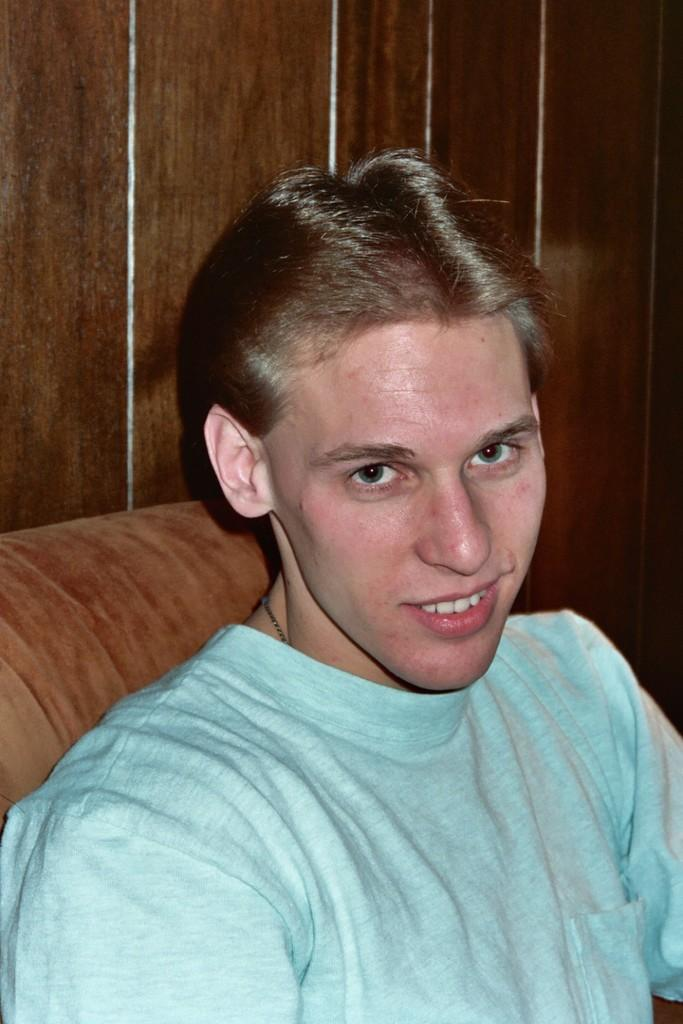Who is present in the image? There is a man in the image. What is the man doing in the image? The man is sitting on a couch. What is the man's facial expression in the image? The man is smiling. What can be seen in the background of the image? There is a wall in the background of the image. What type of bulb is hanging from the ceiling in the image? There is no bulb visible in the image; it only shows a man sitting on a couch and smiling. 